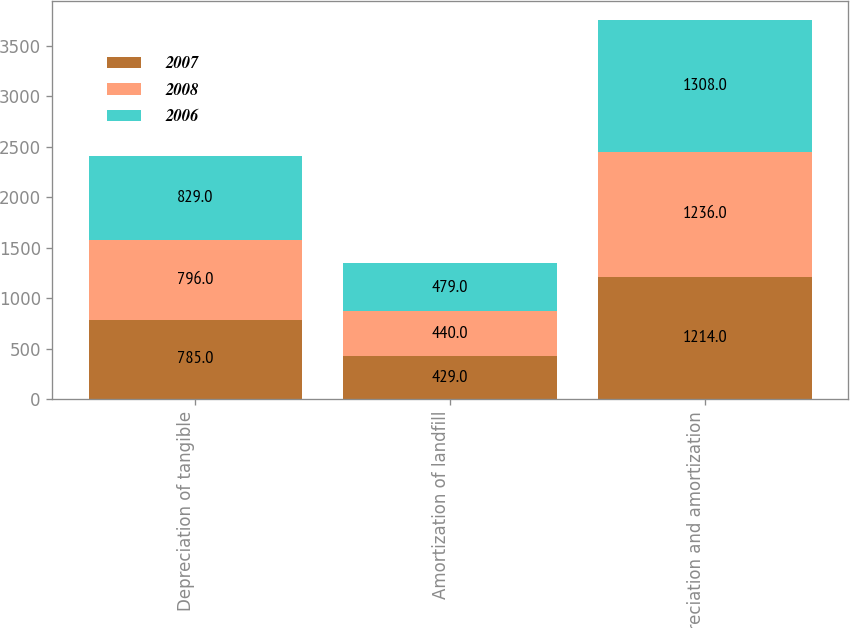<chart> <loc_0><loc_0><loc_500><loc_500><stacked_bar_chart><ecel><fcel>Depreciation of tangible<fcel>Amortization of landfill<fcel>Depreciation and amortization<nl><fcel>2007<fcel>785<fcel>429<fcel>1214<nl><fcel>2008<fcel>796<fcel>440<fcel>1236<nl><fcel>2006<fcel>829<fcel>479<fcel>1308<nl></chart> 